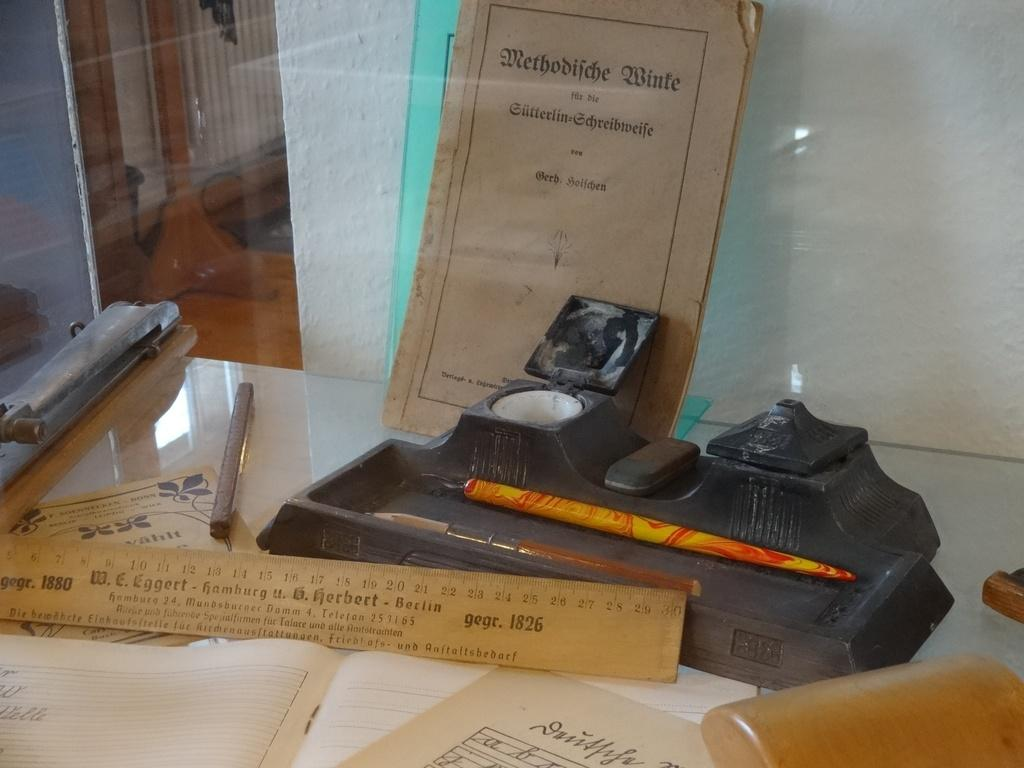Provide a one-sentence caption for the provided image. A ruler and other items that read W.E. Eggert Hamburg. 